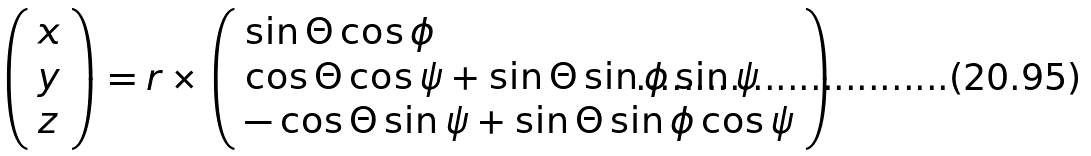<formula> <loc_0><loc_0><loc_500><loc_500>\left ( \begin{array} { l } x \\ y \\ z \end{array} \right ) = r \times \left ( \begin{array} { l } \sin \Theta \cos \phi \\ \cos \Theta \cos \psi + \sin \Theta \sin \phi \sin \psi \\ - \cos \Theta \sin \psi + \sin \Theta \sin \phi \cos \psi \\ \end{array} \right )</formula> 